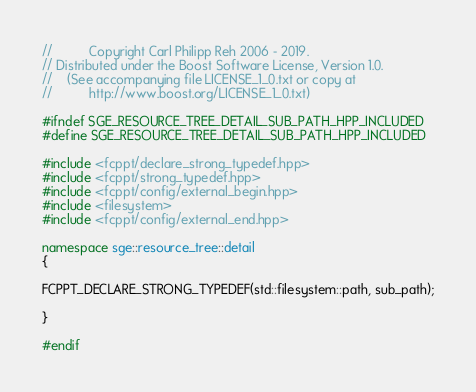Convert code to text. <code><loc_0><loc_0><loc_500><loc_500><_C++_>//          Copyright Carl Philipp Reh 2006 - 2019.
// Distributed under the Boost Software License, Version 1.0.
//    (See accompanying file LICENSE_1_0.txt or copy at
//          http://www.boost.org/LICENSE_1_0.txt)

#ifndef SGE_RESOURCE_TREE_DETAIL_SUB_PATH_HPP_INCLUDED
#define SGE_RESOURCE_TREE_DETAIL_SUB_PATH_HPP_INCLUDED

#include <fcppt/declare_strong_typedef.hpp>
#include <fcppt/strong_typedef.hpp>
#include <fcppt/config/external_begin.hpp>
#include <filesystem>
#include <fcppt/config/external_end.hpp>

namespace sge::resource_tree::detail
{

FCPPT_DECLARE_STRONG_TYPEDEF(std::filesystem::path, sub_path);

}

#endif
</code> 